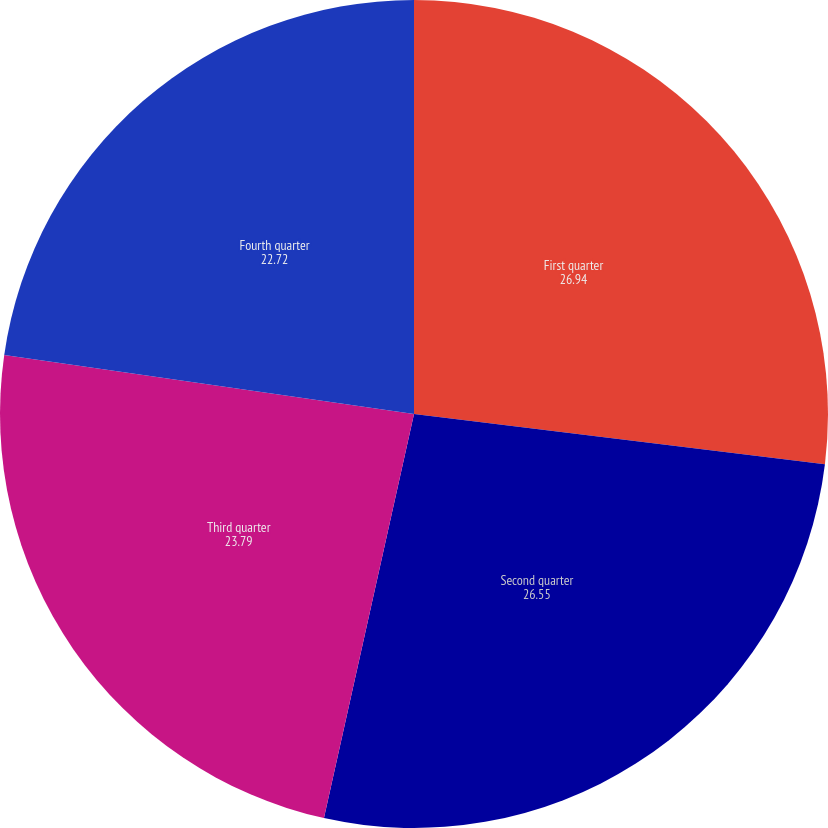Convert chart. <chart><loc_0><loc_0><loc_500><loc_500><pie_chart><fcel>First quarter<fcel>Second quarter<fcel>Third quarter<fcel>Fourth quarter<nl><fcel>26.94%<fcel>26.55%<fcel>23.79%<fcel>22.72%<nl></chart> 